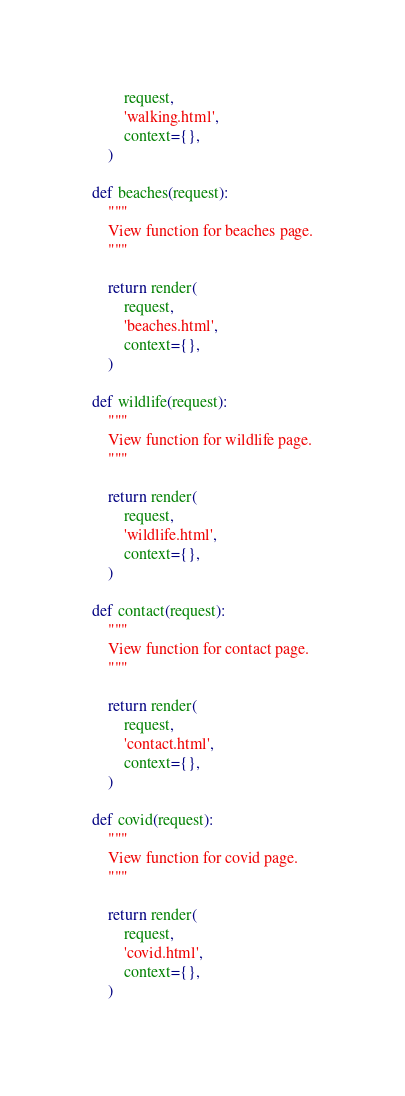<code> <loc_0><loc_0><loc_500><loc_500><_Python_>        request,
        'walking.html',
        context={},
    )

def beaches(request):
    """
    View function for beaches page.
    """

    return render(
        request,
        'beaches.html',
        context={},
    )

def wildlife(request):
    """
    View function for wildlife page.
    """

    return render(
        request,
        'wildlife.html',
        context={},
    )

def contact(request):
    """
    View function for contact page.
    """

    return render(
        request,
        'contact.html',
        context={},
    )

def covid(request):
    """
    View function for covid page.
    """

    return render(
        request,
        'covid.html',
        context={},
    )
</code> 